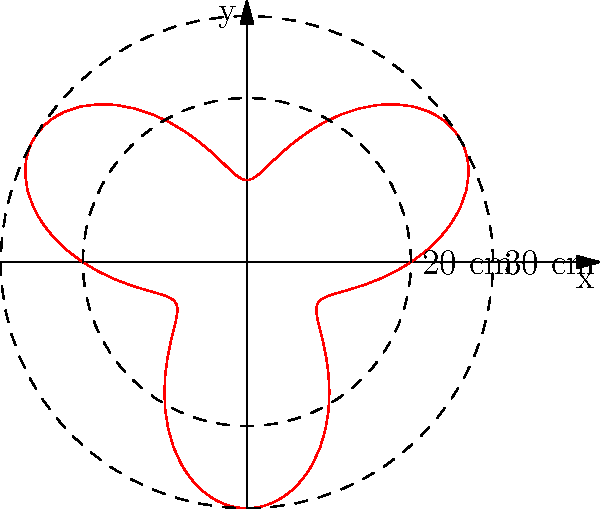The polar curve $r = 20 + 10\sin(3\theta)$ represents the adjustable height range of a compact laptop desk. What is the maximum height adjustment range in centimeters? To find the maximum height adjustment range, we need to:

1. Determine the minimum and maximum values of $r$.

2. For the minimum value:
   $r_{min} = 20 + 10\sin(3\theta)$ when $\sin(3\theta) = -1$
   $r_{min} = 20 + 10(-1) = 10$ cm

3. For the maximum value:
   $r_{max} = 20 + 10\sin(3\theta)$ when $\sin(3\theta) = 1$
   $r_{max} = 20 + 10(1) = 30$ cm

4. Calculate the range:
   Range = $r_{max} - r_{min} = 30 - 10 = 20$ cm

Therefore, the maximum height adjustment range is 20 cm.
Answer: 20 cm 